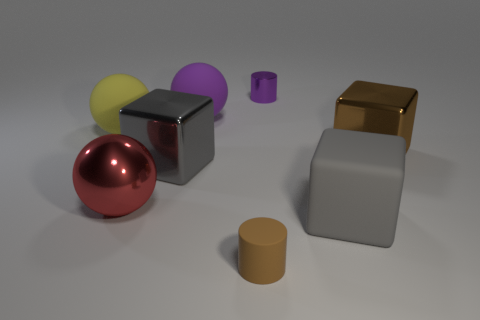Are there any brown blocks?
Provide a succinct answer. Yes. There is a big cube that is on the right side of the gray block that is right of the large cube that is on the left side of the purple cylinder; what is its material?
Offer a very short reply. Metal. Are there fewer metallic blocks left of the small metal cylinder than gray things?
Provide a short and direct response. Yes. There is a purple ball that is the same size as the yellow ball; what is its material?
Make the answer very short. Rubber. How big is the object that is both in front of the brown metallic block and on the right side of the small purple cylinder?
Your response must be concise. Large. There is a purple object that is the same shape as the brown rubber thing; what size is it?
Provide a succinct answer. Small. What number of things are big brown metal blocks or big metal blocks to the right of the purple metallic cylinder?
Your answer should be compact. 1. There is a brown metal thing; what shape is it?
Make the answer very short. Cube. What shape is the purple object behind the purple thing left of the brown matte object?
Give a very brief answer. Cylinder. There is a big cube that is the same color as the rubber cylinder; what material is it?
Keep it short and to the point. Metal. 